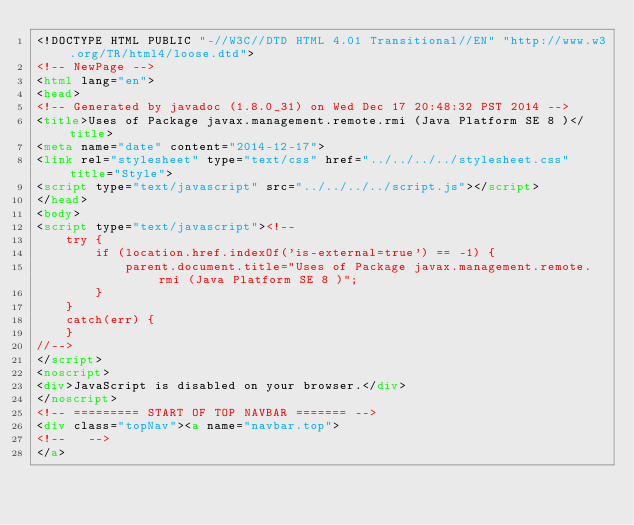<code> <loc_0><loc_0><loc_500><loc_500><_HTML_><!DOCTYPE HTML PUBLIC "-//W3C//DTD HTML 4.01 Transitional//EN" "http://www.w3.org/TR/html4/loose.dtd">
<!-- NewPage -->
<html lang="en">
<head>
<!-- Generated by javadoc (1.8.0_31) on Wed Dec 17 20:48:32 PST 2014 -->
<title>Uses of Package javax.management.remote.rmi (Java Platform SE 8 )</title>
<meta name="date" content="2014-12-17">
<link rel="stylesheet" type="text/css" href="../../../../stylesheet.css" title="Style">
<script type="text/javascript" src="../../../../script.js"></script>
</head>
<body>
<script type="text/javascript"><!--
    try {
        if (location.href.indexOf('is-external=true') == -1) {
            parent.document.title="Uses of Package javax.management.remote.rmi (Java Platform SE 8 )";
        }
    }
    catch(err) {
    }
//-->
</script>
<noscript>
<div>JavaScript is disabled on your browser.</div>
</noscript>
<!-- ========= START OF TOP NAVBAR ======= -->
<div class="topNav"><a name="navbar.top">
<!--   -->
</a></code> 